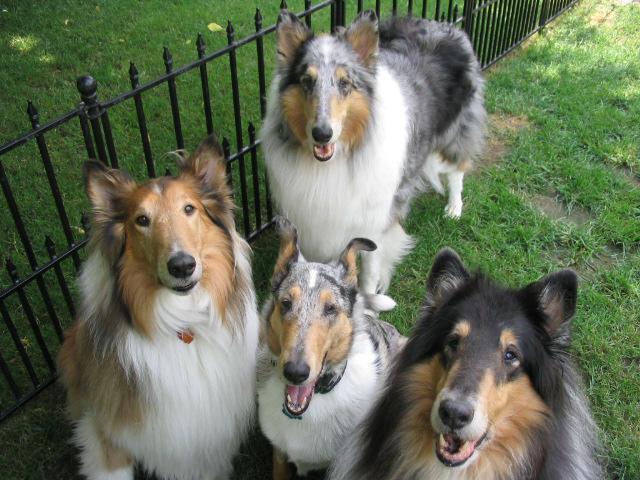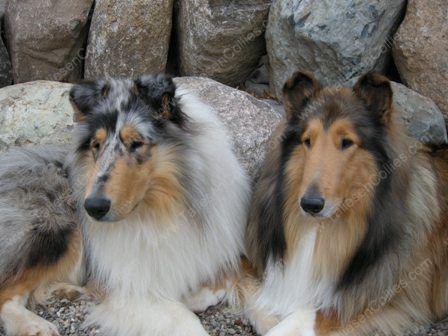The first image is the image on the left, the second image is the image on the right. Evaluate the accuracy of this statement regarding the images: "Two Collies beside each other have their heads cocked to the right.". Is it true? Answer yes or no. No. 